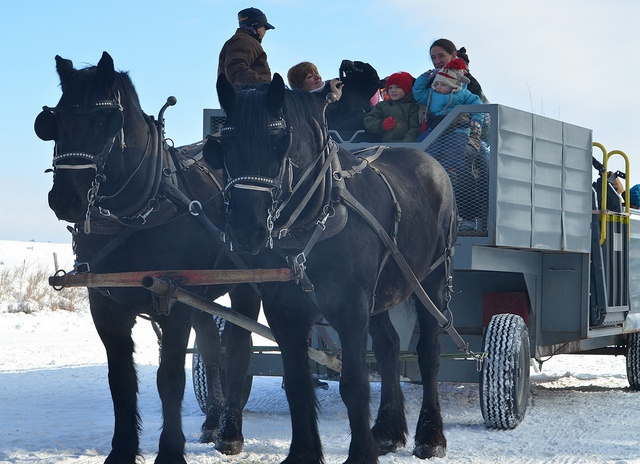Describe the objects in this image and their specific colors. I can see horse in lightblue, black, gray, and darkblue tones, horse in lightblue, black, gray, and darkblue tones, people in lightblue, blue, gray, navy, and teal tones, people in lightblue, black, navy, gray, and darkblue tones, and people in lightblue, black, and gray tones in this image. 